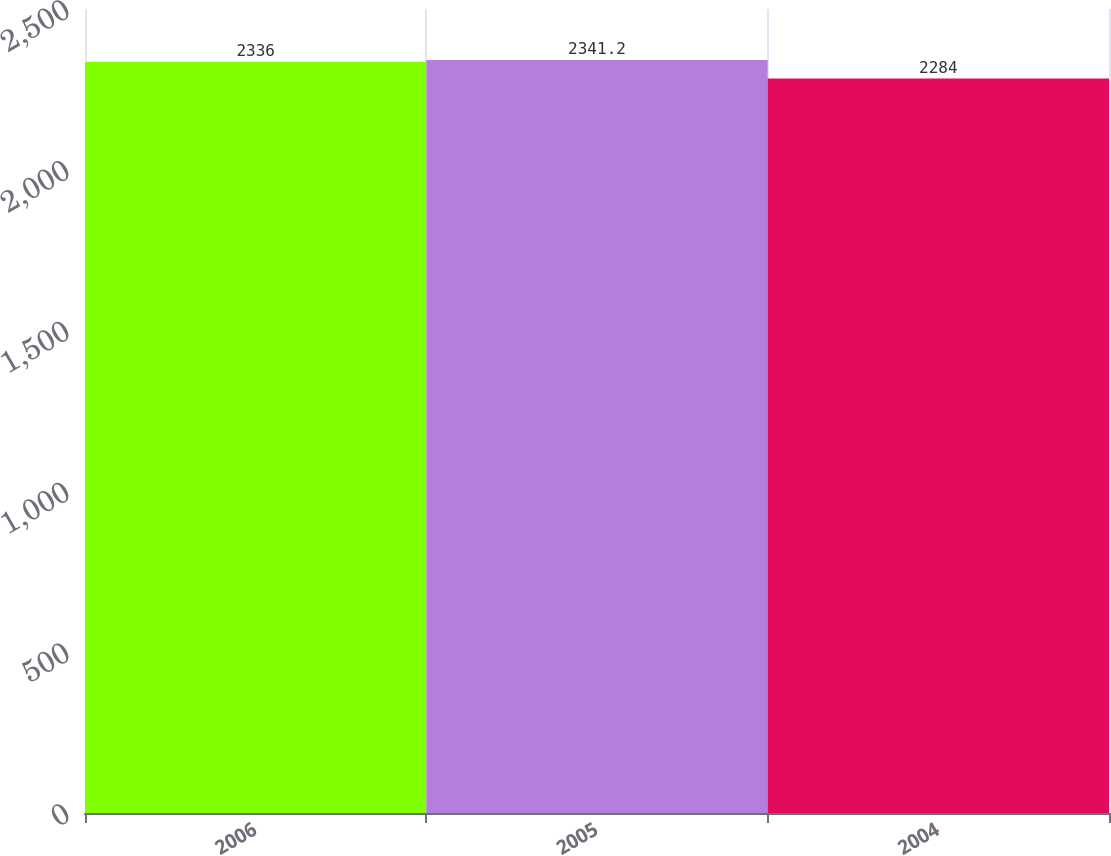Convert chart to OTSL. <chart><loc_0><loc_0><loc_500><loc_500><bar_chart><fcel>2006<fcel>2005<fcel>2004<nl><fcel>2336<fcel>2341.2<fcel>2284<nl></chart> 